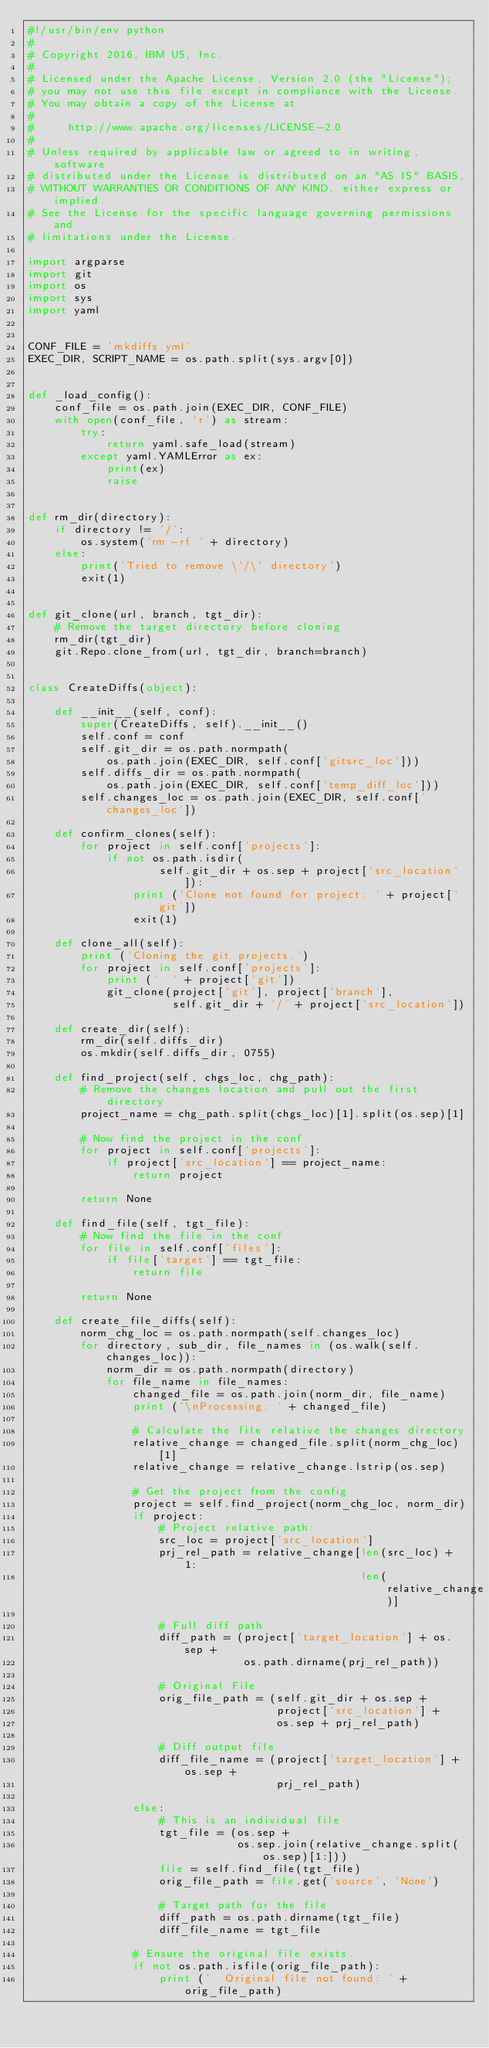Convert code to text. <code><loc_0><loc_0><loc_500><loc_500><_Python_>#!/usr/bin/env python
#
# Copyright 2016, IBM US, Inc.
#
# Licensed under the Apache License, Version 2.0 (the "License");
# you may not use this file except in compliance with the License.
# You may obtain a copy of the License at
#
#     http://www.apache.org/licenses/LICENSE-2.0
#
# Unless required by applicable law or agreed to in writing, software
# distributed under the License is distributed on an "AS IS" BASIS,
# WITHOUT WARRANTIES OR CONDITIONS OF ANY KIND, either express or implied.
# See the License for the specific language governing permissions and
# limitations under the License.

import argparse
import git
import os
import sys
import yaml


CONF_FILE = 'mkdiffs.yml'
EXEC_DIR, SCRIPT_NAME = os.path.split(sys.argv[0])


def _load_config():
    conf_file = os.path.join(EXEC_DIR, CONF_FILE)
    with open(conf_file, 'r') as stream:
        try:
            return yaml.safe_load(stream)
        except yaml.YAMLError as ex:
            print(ex)
            raise


def rm_dir(directory):
    if directory != '/':
        os.system('rm -rf ' + directory)
    else:
        print('Tried to remove \'/\' directory')
        exit(1)


def git_clone(url, branch, tgt_dir):
    # Remove the target directory before cloning
    rm_dir(tgt_dir)
    git.Repo.clone_from(url, tgt_dir, branch=branch)


class CreateDiffs(object):

    def __init__(self, conf):
        super(CreateDiffs, self).__init__()
        self.conf = conf
        self.git_dir = os.path.normpath(
            os.path.join(EXEC_DIR, self.conf['gitsrc_loc']))
        self.diffs_dir = os.path.normpath(
            os.path.join(EXEC_DIR, self.conf['temp_diff_loc']))
        self.changes_loc = os.path.join(EXEC_DIR, self.conf['changes_loc'])

    def confirm_clones(self):
        for project in self.conf['projects']:
            if not os.path.isdir(
                    self.git_dir + os.sep + project['src_location']):
                print ('Clone not found for project: ' + project['git'])
                exit(1)

    def clone_all(self):
        print ('Cloning the git projects.')
        for project in self.conf['projects']:
            print ('  ' + project['git'])
            git_clone(project['git'], project['branch'],
                      self.git_dir + '/' + project['src_location'])

    def create_dir(self):
        rm_dir(self.diffs_dir)
        os.mkdir(self.diffs_dir, 0755)

    def find_project(self, chgs_loc, chg_path):
        # Remove the changes location and pull out the first directory
        project_name = chg_path.split(chgs_loc)[1].split(os.sep)[1]

        # Now find the project in the conf
        for project in self.conf['projects']:
            if project['src_location'] == project_name:
                return project

        return None

    def find_file(self, tgt_file):
        # Now find the file in the conf
        for file in self.conf['files']:
            if file['target'] == tgt_file:
                return file

        return None

    def create_file_diffs(self):
        norm_chg_loc = os.path.normpath(self.changes_loc)
        for directory, sub_dir, file_names in (os.walk(self.changes_loc)):
            norm_dir = os.path.normpath(directory)
            for file_name in file_names:
                changed_file = os.path.join(norm_dir, file_name)
                print ('\nProcessing: ' + changed_file)

                # Calculate the file relative the changes directory
                relative_change = changed_file.split(norm_chg_loc)[1]
                relative_change = relative_change.lstrip(os.sep)

                # Get the project from the config
                project = self.find_project(norm_chg_loc, norm_dir)
                if project:
                    # Project relative path:
                    src_loc = project['src_location']
                    prj_rel_path = relative_change[len(src_loc) + 1:
                                                   len(relative_change)]

                    # Full diff path
                    diff_path = (project['target_location'] + os.sep +
                                 os.path.dirname(prj_rel_path))

                    # Original File
                    orig_file_path = (self.git_dir + os.sep +
                                      project['src_location'] +
                                      os.sep + prj_rel_path)

                    # Diff output file
                    diff_file_name = (project['target_location'] + os.sep +
                                      prj_rel_path)

                else:
                    # This is an individual file
                    tgt_file = (os.sep +
                                os.sep.join(relative_change.split(os.sep)[1:]))
                    file = self.find_file(tgt_file)
                    orig_file_path = file.get('source', 'None')

                    # Target path for the file
                    diff_path = os.path.dirname(tgt_file)
                    diff_file_name = tgt_file

                # Ensure the original file exists.
                if not os.path.isfile(orig_file_path):
                    print ('  Original file not found: ' + orig_file_path)</code> 